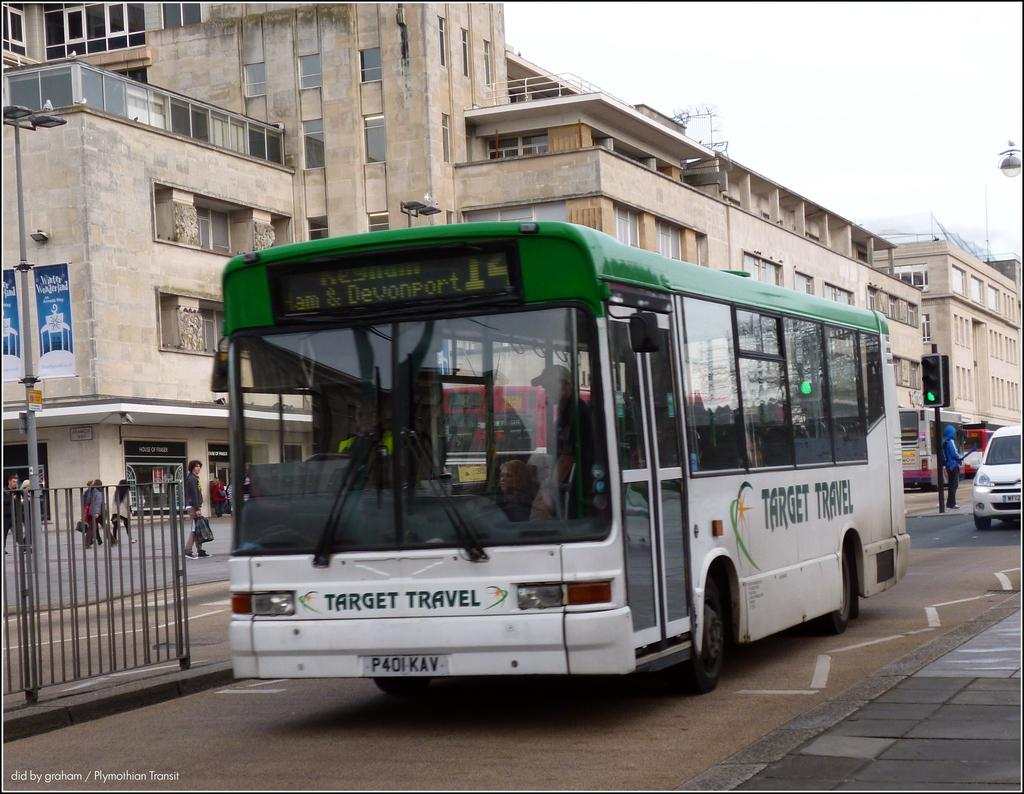<image>
Render a clear and concise summary of the photo. Target travel green and white bus is parked on a stree 